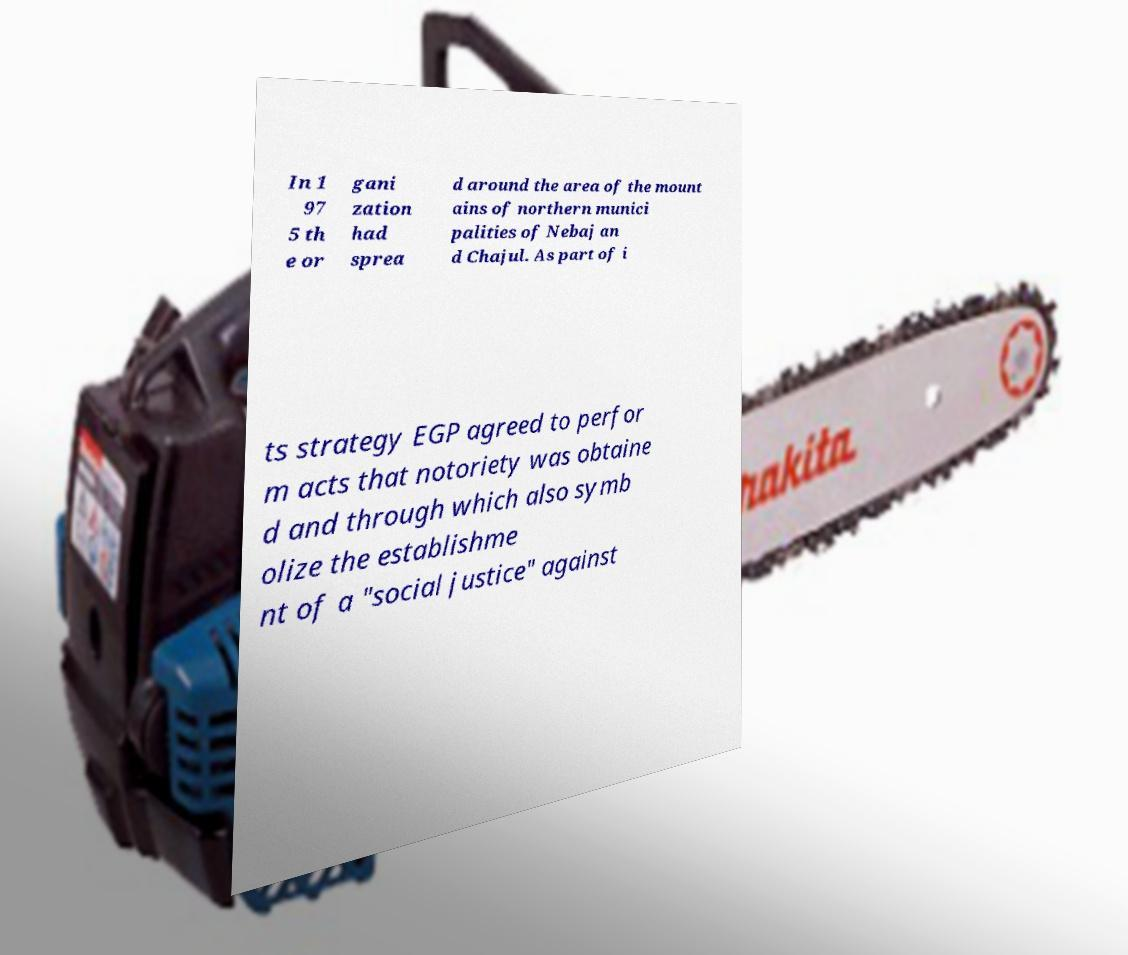I need the written content from this picture converted into text. Can you do that? In 1 97 5 th e or gani zation had sprea d around the area of the mount ains of northern munici palities of Nebaj an d Chajul. As part of i ts strategy EGP agreed to perfor m acts that notoriety was obtaine d and through which also symb olize the establishme nt of a "social justice" against 